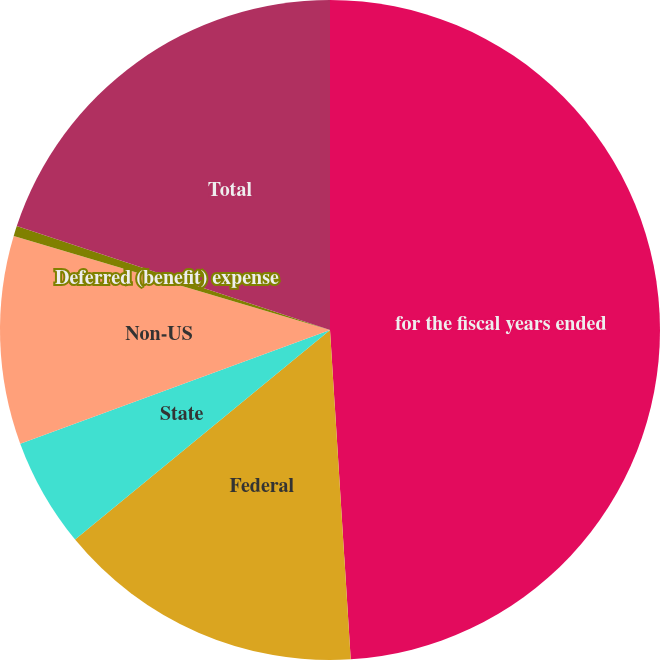Convert chart. <chart><loc_0><loc_0><loc_500><loc_500><pie_chart><fcel>for the fiscal years ended<fcel>Federal<fcel>State<fcel>Non-US<fcel>Deferred (benefit) expense<fcel>Total<nl><fcel>49.0%<fcel>15.05%<fcel>5.35%<fcel>10.2%<fcel>0.5%<fcel>19.9%<nl></chart> 